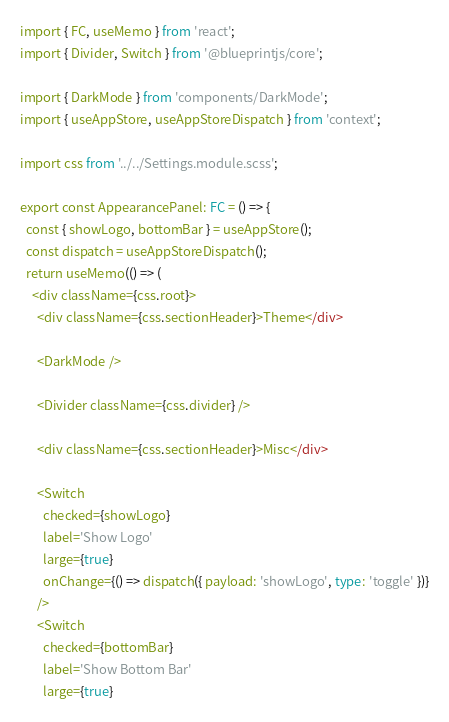<code> <loc_0><loc_0><loc_500><loc_500><_TypeScript_>import { FC, useMemo } from 'react';
import { Divider, Switch } from '@blueprintjs/core';

import { DarkMode } from 'components/DarkMode';
import { useAppStore, useAppStoreDispatch } from 'context';

import css from '../../Settings.module.scss';

export const AppearancePanel: FC = () => {
  const { showLogo, bottomBar } = useAppStore();
  const dispatch = useAppStoreDispatch();
  return useMemo(() => (
    <div className={css.root}>
      <div className={css.sectionHeader}>Theme</div>

      <DarkMode />

      <Divider className={css.divider} />

      <div className={css.sectionHeader}>Misc</div>

      <Switch
        checked={showLogo}
        label='Show Logo'
        large={true}
        onChange={() => dispatch({ payload: 'showLogo', type: 'toggle' })}
      />
      <Switch
        checked={bottomBar}
        label='Show Bottom Bar'
        large={true}</code> 